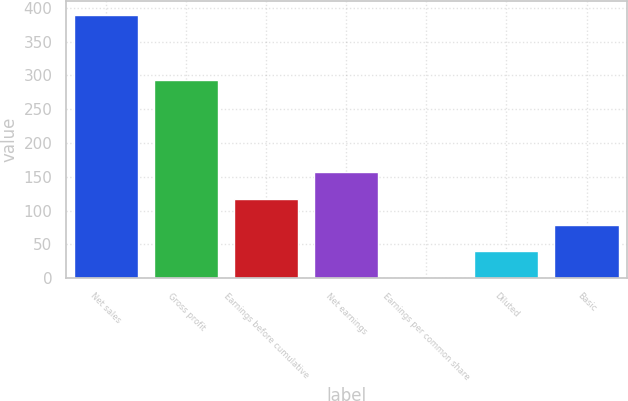Convert chart to OTSL. <chart><loc_0><loc_0><loc_500><loc_500><bar_chart><fcel>Net sales<fcel>Gross profit<fcel>Earnings before cumulative<fcel>Net earnings<fcel>Earnings per common share<fcel>Diluted<fcel>Basic<nl><fcel>390.1<fcel>293.2<fcel>117.32<fcel>156.29<fcel>0.41<fcel>39.38<fcel>78.35<nl></chart> 